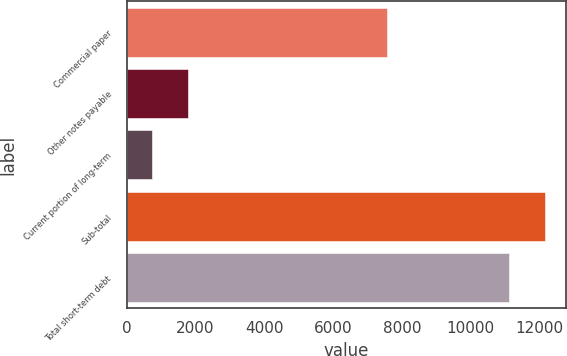<chart> <loc_0><loc_0><loc_500><loc_500><bar_chart><fcel>Commercial paper<fcel>Other notes payable<fcel>Current portion of long-term<fcel>Sub-total<fcel>Total short-term debt<nl><fcel>7563<fcel>1786.9<fcel>740<fcel>12160.9<fcel>11114<nl></chart> 